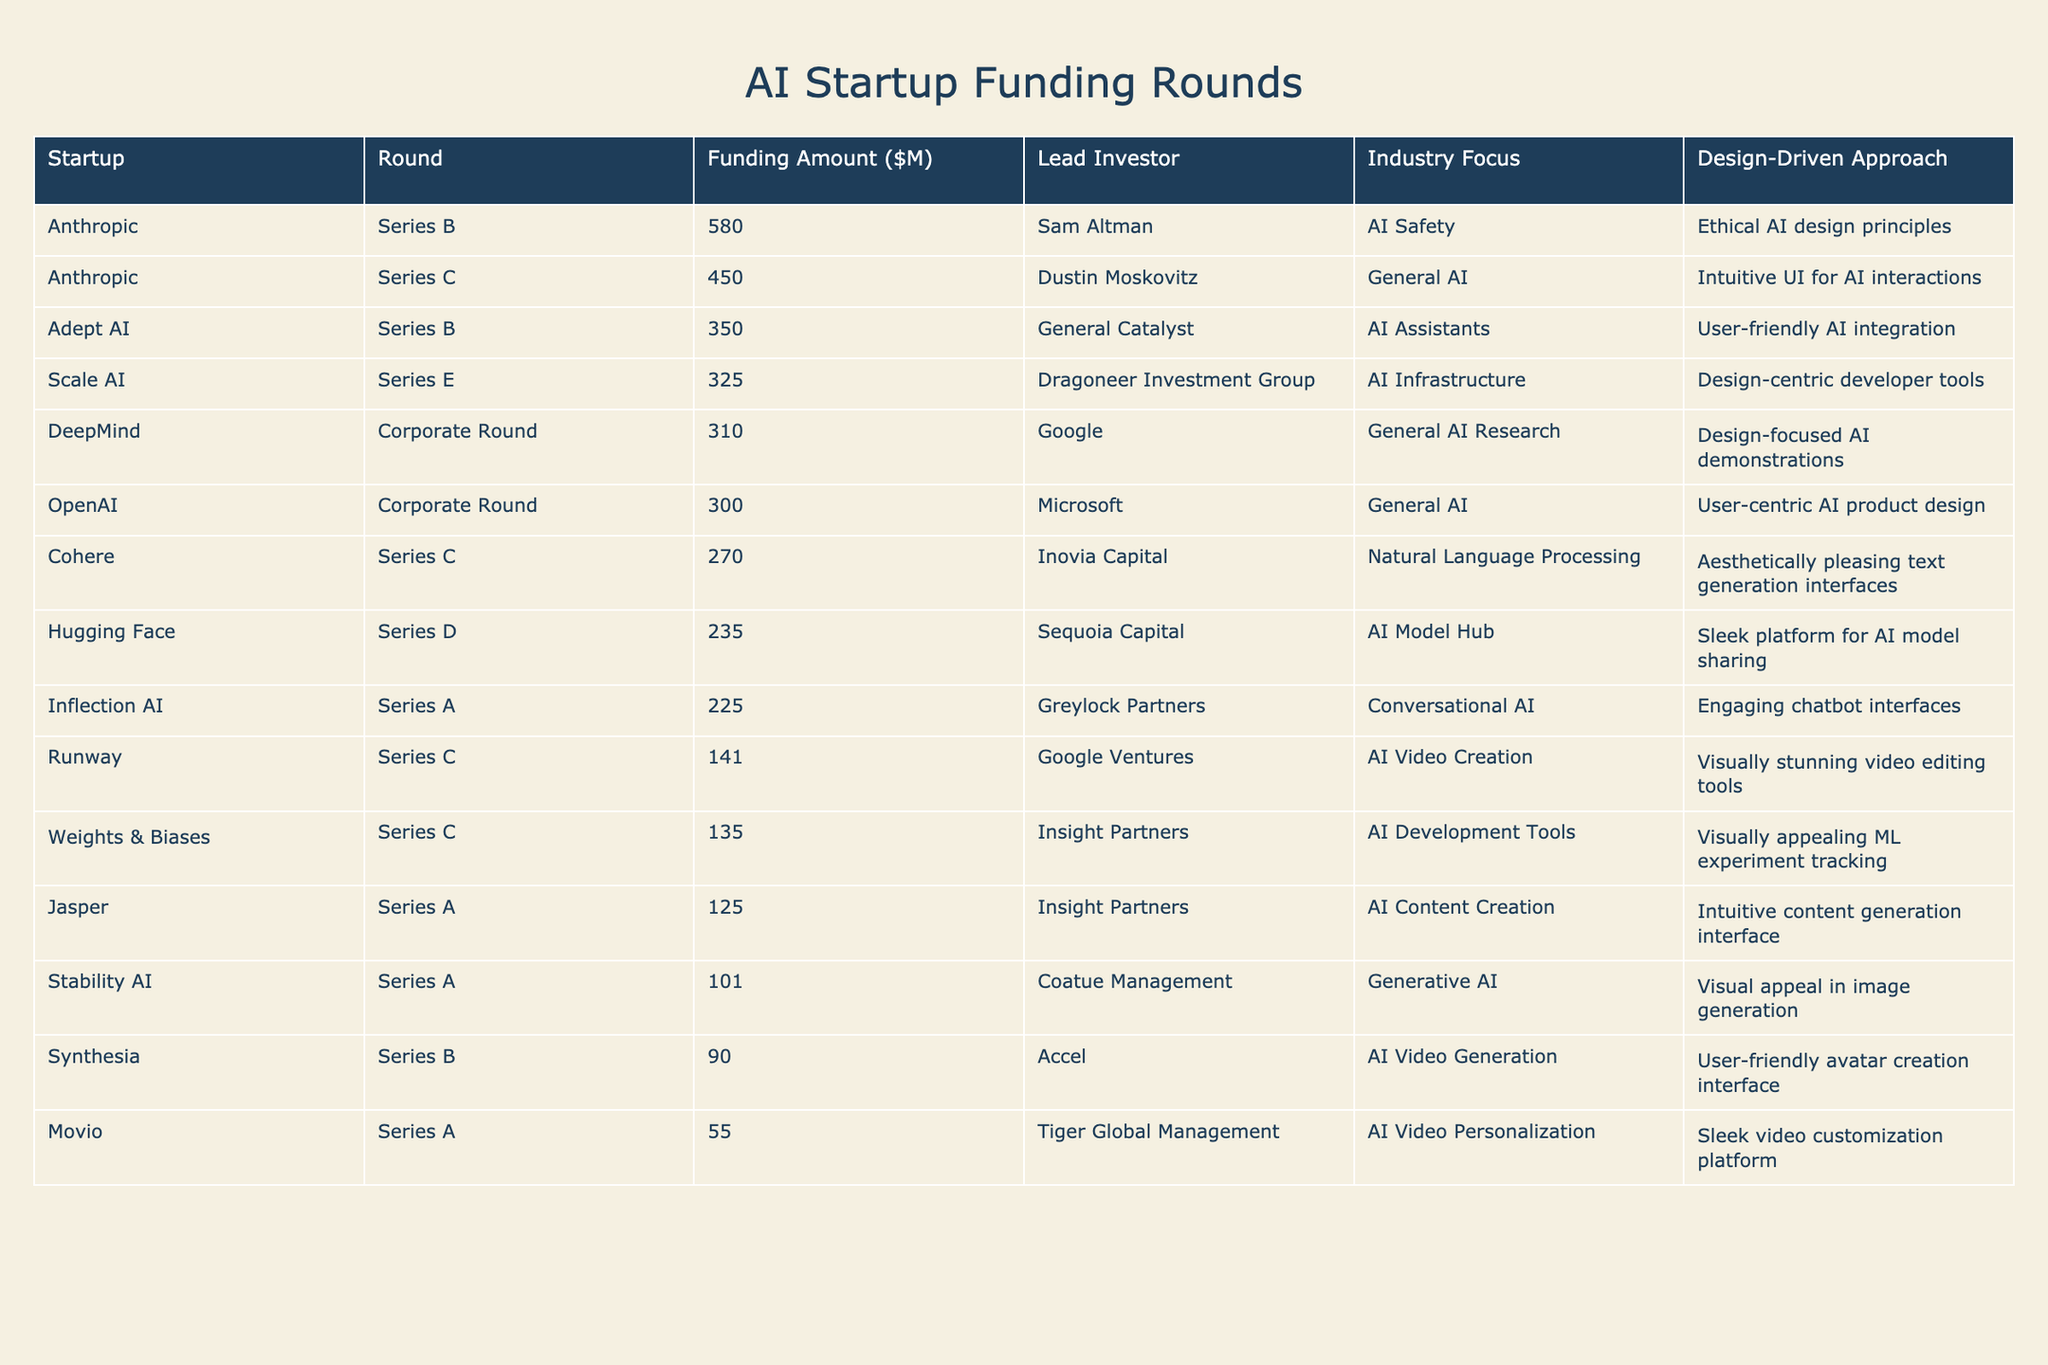What is the highest funding amount in the table? The highest funding amount can be found by looking at the "Funding Amount ($M)" column and identifying the largest number. The largest value is 580 from Anthropic in Series B.
Answer: 580 Which startup received the least funding amount? To find the least funding amount, we examine the "Funding Amount ($M)" column and identify the smallest number. The smallest value is 55 from Movio in Series A.
Answer: 55 How many funding rounds are mentioned for the startups? By counting the unique entries in the "Round" column, we find that there are six different rounds mentioned: Series A, Series B, Series C, Series D, Series E, and Corporate Round.
Answer: 6 Which lead investor participated in the highest funding round? We check the "Lead Investor" column associated with the highest funding amount, which is 580 by Sam Altman for Anthropic in Series B. Therefore, the lead investor for the highest round is Sam Altman.
Answer: Sam Altman Is there a startup that received less than 100 million in funding? We review the "Funding Amount ($M)" column to see if any amount is below 100 million. Movio received 55 million, which is indeed less than 100 million, confirming that there is such a startup.
Answer: Yes What is the total funding amount for Series C rounds? We look at the "Round" column and sum up the funding amounts for all Series C entries: 450 (Anthropic) + 270 (Cohere) + 135 (Weights & Biases) + 141 (Runway) = 996 million. The total funding for Series C is thus 996 million.
Answer: 996 How many startups have a design-driven approach focused on user-friendly interfaces? We categorize startups using the "Design-Driven Approach" column that emphasizes user-friendly designs. Three startups are identified: Adept AI, Inflection AI, and Synthesia, confirming this focus.
Answer: 3 Which industry focus received the most funding in total? We segregate the total funding by industry. General AI has 450 (Anthropic, Series C), 580 (Anthropic, Series B), and 310 (DeepMind). AI Video Creation has 141 (Runway) and AI Video Personalization has 55 (Movio). Aggregating these amounts shows that General AI received the highest total funding.
Answer: General AI What percentage of the total funding is represented by DeepMind's funding? First, we find DeepMind's funding amount, which is 310 million. Next, we calculate the total funding amount from the table, which is 3,119 million. The percentage is then calculated as (310 / 3119) * 100 ≈ 9.93%. Thus, the percentage of total funding represented by DeepMind is about 9.93%.
Answer: 9.93% Which two startups have the highest funding amounts after Anthropic? After finding Anthropic’s highest funding (580 million), we look at the next highest values, which are 450 million (Anthropic, Series C) and 350 million (Adept AI, Series B). Thus, the two startups following Anthropic in funding amounts are Anthropic (Series C) and Adept AI.
Answer: Anthropic (Series C) and Adept AI 